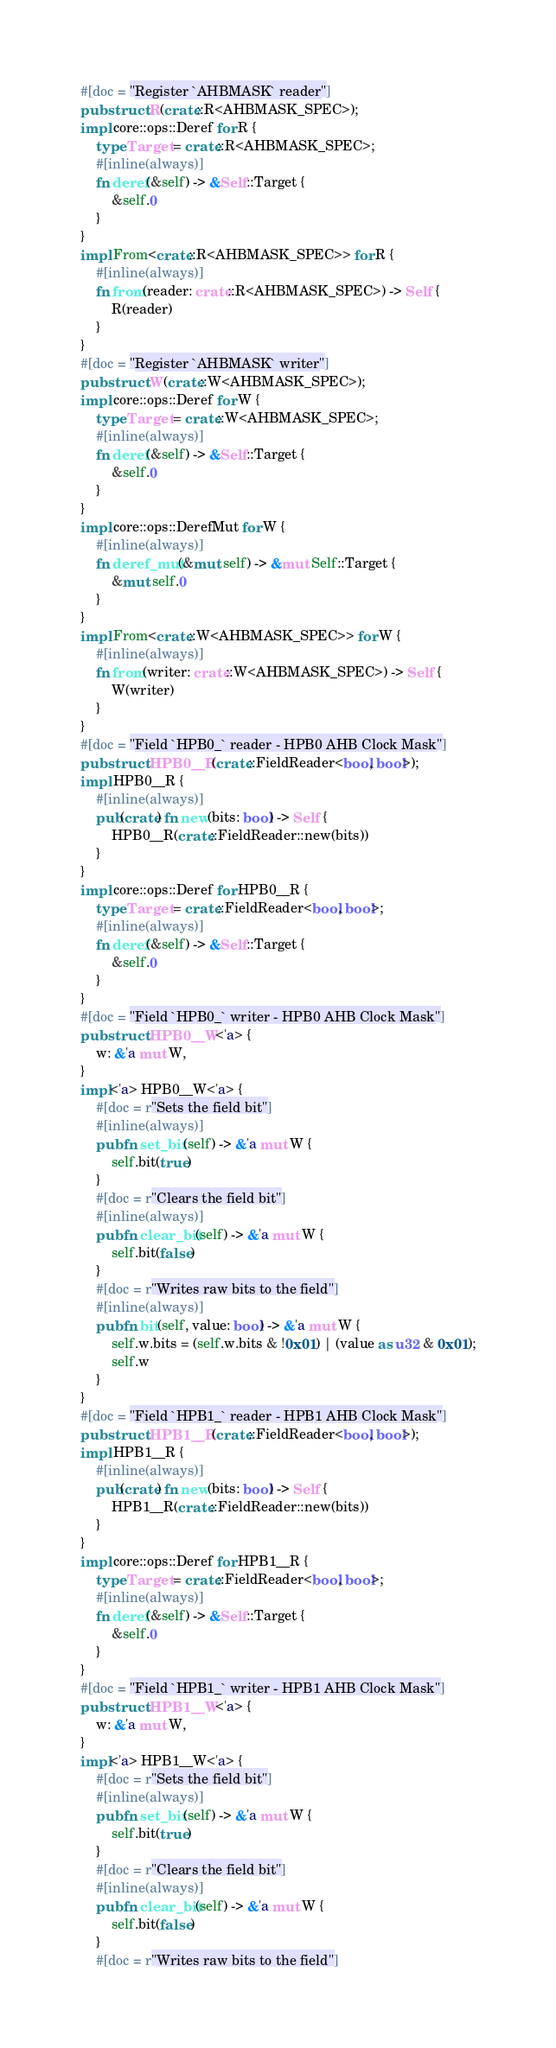Convert code to text. <code><loc_0><loc_0><loc_500><loc_500><_Rust_>#[doc = "Register `AHBMASK` reader"]
pub struct R(crate::R<AHBMASK_SPEC>);
impl core::ops::Deref for R {
    type Target = crate::R<AHBMASK_SPEC>;
    #[inline(always)]
    fn deref(&self) -> &Self::Target {
        &self.0
    }
}
impl From<crate::R<AHBMASK_SPEC>> for R {
    #[inline(always)]
    fn from(reader: crate::R<AHBMASK_SPEC>) -> Self {
        R(reader)
    }
}
#[doc = "Register `AHBMASK` writer"]
pub struct W(crate::W<AHBMASK_SPEC>);
impl core::ops::Deref for W {
    type Target = crate::W<AHBMASK_SPEC>;
    #[inline(always)]
    fn deref(&self) -> &Self::Target {
        &self.0
    }
}
impl core::ops::DerefMut for W {
    #[inline(always)]
    fn deref_mut(&mut self) -> &mut Self::Target {
        &mut self.0
    }
}
impl From<crate::W<AHBMASK_SPEC>> for W {
    #[inline(always)]
    fn from(writer: crate::W<AHBMASK_SPEC>) -> Self {
        W(writer)
    }
}
#[doc = "Field `HPB0_` reader - HPB0 AHB Clock Mask"]
pub struct HPB0__R(crate::FieldReader<bool, bool>);
impl HPB0__R {
    #[inline(always)]
    pub(crate) fn new(bits: bool) -> Self {
        HPB0__R(crate::FieldReader::new(bits))
    }
}
impl core::ops::Deref for HPB0__R {
    type Target = crate::FieldReader<bool, bool>;
    #[inline(always)]
    fn deref(&self) -> &Self::Target {
        &self.0
    }
}
#[doc = "Field `HPB0_` writer - HPB0 AHB Clock Mask"]
pub struct HPB0__W<'a> {
    w: &'a mut W,
}
impl<'a> HPB0__W<'a> {
    #[doc = r"Sets the field bit"]
    #[inline(always)]
    pub fn set_bit(self) -> &'a mut W {
        self.bit(true)
    }
    #[doc = r"Clears the field bit"]
    #[inline(always)]
    pub fn clear_bit(self) -> &'a mut W {
        self.bit(false)
    }
    #[doc = r"Writes raw bits to the field"]
    #[inline(always)]
    pub fn bit(self, value: bool) -> &'a mut W {
        self.w.bits = (self.w.bits & !0x01) | (value as u32 & 0x01);
        self.w
    }
}
#[doc = "Field `HPB1_` reader - HPB1 AHB Clock Mask"]
pub struct HPB1__R(crate::FieldReader<bool, bool>);
impl HPB1__R {
    #[inline(always)]
    pub(crate) fn new(bits: bool) -> Self {
        HPB1__R(crate::FieldReader::new(bits))
    }
}
impl core::ops::Deref for HPB1__R {
    type Target = crate::FieldReader<bool, bool>;
    #[inline(always)]
    fn deref(&self) -> &Self::Target {
        &self.0
    }
}
#[doc = "Field `HPB1_` writer - HPB1 AHB Clock Mask"]
pub struct HPB1__W<'a> {
    w: &'a mut W,
}
impl<'a> HPB1__W<'a> {
    #[doc = r"Sets the field bit"]
    #[inline(always)]
    pub fn set_bit(self) -> &'a mut W {
        self.bit(true)
    }
    #[doc = r"Clears the field bit"]
    #[inline(always)]
    pub fn clear_bit(self) -> &'a mut W {
        self.bit(false)
    }
    #[doc = r"Writes raw bits to the field"]</code> 